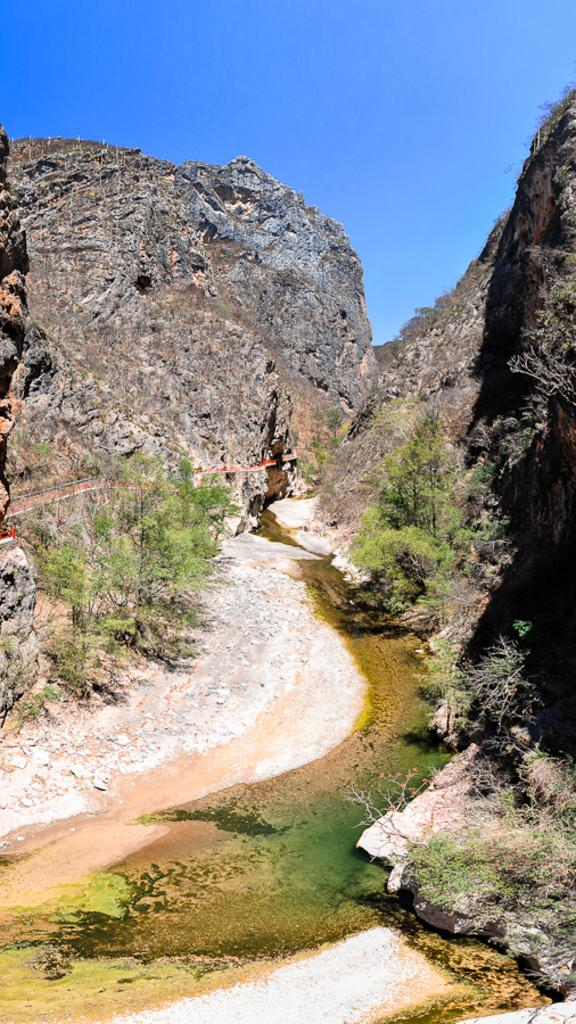What can be seen at the top of the image? The sky is visible towards the top of the image. What type of geographical feature is present in the image? There are rocky mountains in the image. What type of vegetation is present in the image? There are plants in the image. What type of organism is present on the ground in the image? Green algae is present on the ground. What idea is being expressed by the wax in the image? There is no wax present in the image, so no idea can be expressed by it. 